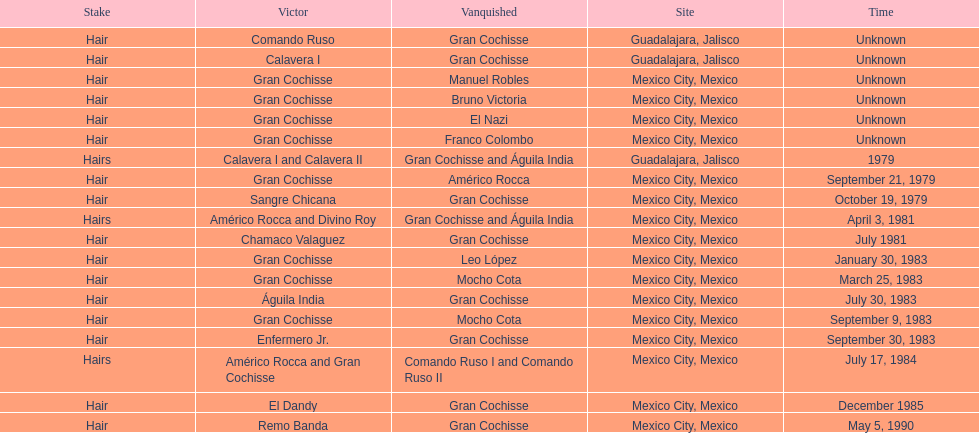Can you give me this table as a dict? {'header': ['Stake', 'Victor', 'Vanquished', 'Site', 'Time'], 'rows': [['Hair', 'Comando Ruso', 'Gran Cochisse', 'Guadalajara, Jalisco', 'Unknown'], ['Hair', 'Calavera I', 'Gran Cochisse', 'Guadalajara, Jalisco', 'Unknown'], ['Hair', 'Gran Cochisse', 'Manuel Robles', 'Mexico City, Mexico', 'Unknown'], ['Hair', 'Gran Cochisse', 'Bruno Victoria', 'Mexico City, Mexico', 'Unknown'], ['Hair', 'Gran Cochisse', 'El Nazi', 'Mexico City, Mexico', 'Unknown'], ['Hair', 'Gran Cochisse', 'Franco Colombo', 'Mexico City, Mexico', 'Unknown'], ['Hairs', 'Calavera I and Calavera II', 'Gran Cochisse and Águila India', 'Guadalajara, Jalisco', '1979'], ['Hair', 'Gran Cochisse', 'Américo Rocca', 'Mexico City, Mexico', 'September 21, 1979'], ['Hair', 'Sangre Chicana', 'Gran Cochisse', 'Mexico City, Mexico', 'October 19, 1979'], ['Hairs', 'Américo Rocca and Divino Roy', 'Gran Cochisse and Águila India', 'Mexico City, Mexico', 'April 3, 1981'], ['Hair', 'Chamaco Valaguez', 'Gran Cochisse', 'Mexico City, Mexico', 'July 1981'], ['Hair', 'Gran Cochisse', 'Leo López', 'Mexico City, Mexico', 'January 30, 1983'], ['Hair', 'Gran Cochisse', 'Mocho Cota', 'Mexico City, Mexico', 'March 25, 1983'], ['Hair', 'Águila India', 'Gran Cochisse', 'Mexico City, Mexico', 'July 30, 1983'], ['Hair', 'Gran Cochisse', 'Mocho Cota', 'Mexico City, Mexico', 'September 9, 1983'], ['Hair', 'Enfermero Jr.', 'Gran Cochisse', 'Mexico City, Mexico', 'September 30, 1983'], ['Hairs', 'Américo Rocca and Gran Cochisse', 'Comando Ruso I and Comando Ruso II', 'Mexico City, Mexico', 'July 17, 1984'], ['Hair', 'El Dandy', 'Gran Cochisse', 'Mexico City, Mexico', 'December 1985'], ['Hair', 'Remo Banda', 'Gran Cochisse', 'Mexico City, Mexico', 'May 5, 1990']]} What was the number of losses gran cochisse had against el dandy? 1. 